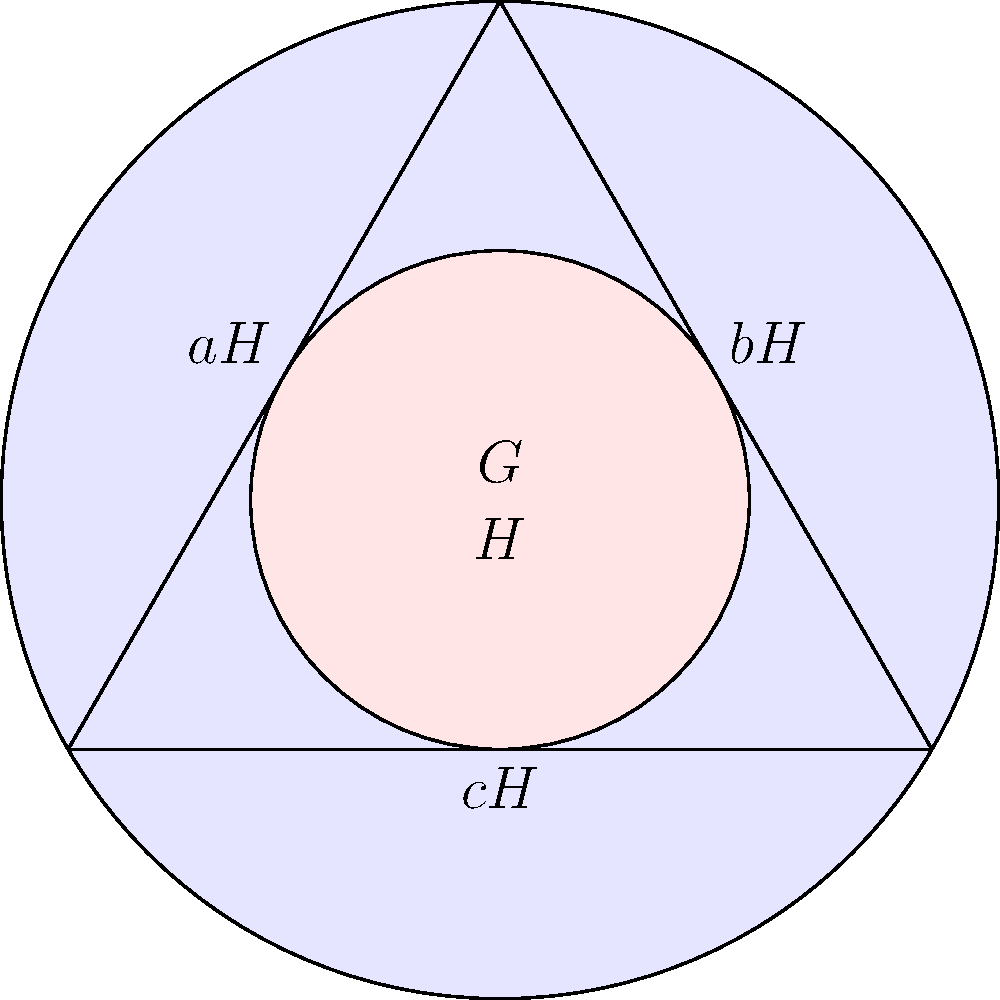In the context of group theory and secure software development, consider a finite group $G$ represented by the outer circle in the Venn diagram. The inner circle represents a subgroup $H$ of $G$. The triangle represents the set of cosets of $H$ in $G$. If $|G| = 18$ and $|H| = 6$, how many elements are in each coset of $H$ in $G$, and how does this relate to the Lagrange's theorem often used in cryptographic algorithms? Let's approach this step-by-step:

1) First, recall Lagrange's theorem: For a finite group $G$ and a subgroup $H$ of $G$, the order of $H$ divides the order of $G$. Mathematically, $|G| = |H| \cdot [G:H]$, where $[G:H]$ is the index of $H$ in $G$.

2) We're given that $|G| = 18$ and $|H| = 6$.

3) The index $[G:H]$ is the number of cosets of $H$ in $G$. We can calculate this:
   $[G:H] = |G| / |H| = 18 / 6 = 3$

4) This means there are 3 cosets of $H$ in $G$, which corresponds to the three regions of the triangle in our diagram.

5) Now, a key property of cosets is that they all have the same number of elements as the subgroup $H$. This is because cosets are formed by multiplying each element of $H$ by a fixed element of $G$.

6) Therefore, each coset has $|H| = 6$ elements.

7) We can verify this: $3$ cosets * $6$ elements per coset = $18$ total elements, which matches $|G|$.

8) In cryptography, Lagrange's theorem is often used in algorithms related to discrete logarithms and in the analysis of cyclic groups. For example, in RSA encryption, it's used to prove the correctness of the decryption process.

9) The concept of cosets is crucial in understanding quotient groups, which have applications in error-correcting codes used in secure data transmission.
Answer: 6 elements per coset; Lagrange's theorem ensures consistent coset size, crucial for cryptographic group operations. 